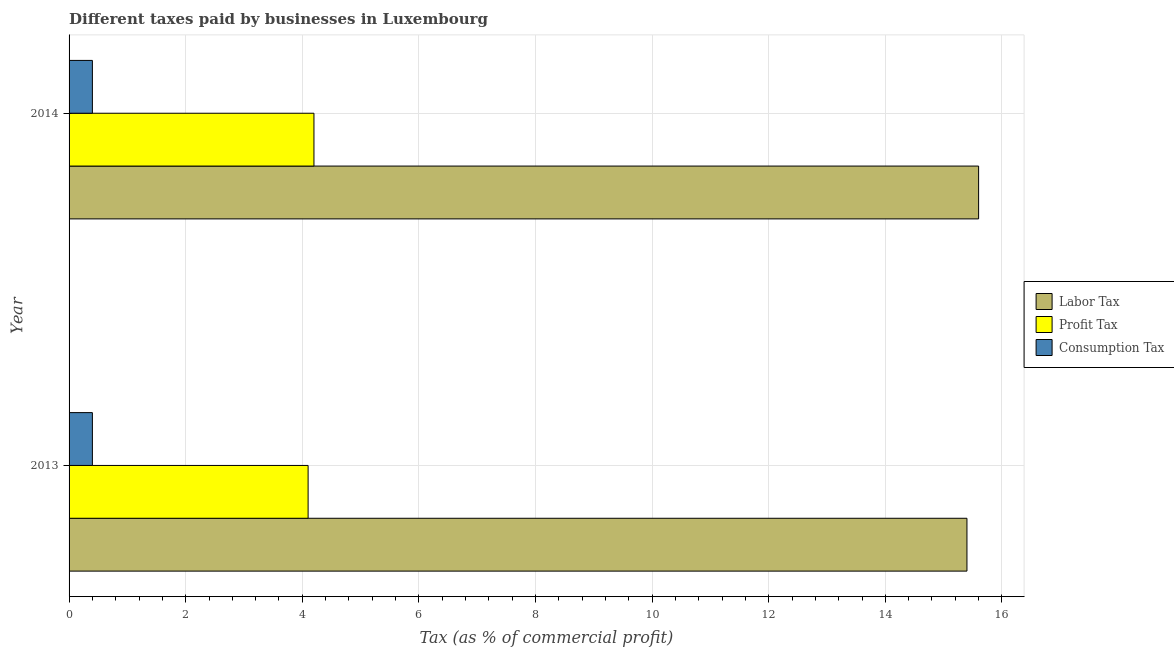How many different coloured bars are there?
Your response must be concise. 3. Are the number of bars per tick equal to the number of legend labels?
Keep it short and to the point. Yes. Are the number of bars on each tick of the Y-axis equal?
Keep it short and to the point. Yes. How many bars are there on the 2nd tick from the top?
Your response must be concise. 3. What is the label of the 1st group of bars from the top?
Ensure brevity in your answer.  2014. What is the percentage of consumption tax in 2014?
Your response must be concise. 0.4. Across all years, what is the maximum percentage of consumption tax?
Provide a short and direct response. 0.4. In which year was the percentage of consumption tax minimum?
Your answer should be very brief. 2013. What is the total percentage of consumption tax in the graph?
Your response must be concise. 0.8. What is the difference between the percentage of labor tax in 2013 and the percentage of consumption tax in 2014?
Keep it short and to the point. 15. What is the average percentage of consumption tax per year?
Provide a short and direct response. 0.4. What is the ratio of the percentage of consumption tax in 2013 to that in 2014?
Ensure brevity in your answer.  1. Is the percentage of profit tax in 2013 less than that in 2014?
Your answer should be very brief. Yes. Is the difference between the percentage of profit tax in 2013 and 2014 greater than the difference between the percentage of consumption tax in 2013 and 2014?
Keep it short and to the point. No. In how many years, is the percentage of consumption tax greater than the average percentage of consumption tax taken over all years?
Make the answer very short. 0. What does the 3rd bar from the top in 2013 represents?
Keep it short and to the point. Labor Tax. What does the 3rd bar from the bottom in 2014 represents?
Provide a short and direct response. Consumption Tax. What is the difference between two consecutive major ticks on the X-axis?
Provide a short and direct response. 2. Are the values on the major ticks of X-axis written in scientific E-notation?
Provide a succinct answer. No. Where does the legend appear in the graph?
Make the answer very short. Center right. How are the legend labels stacked?
Keep it short and to the point. Vertical. What is the title of the graph?
Provide a short and direct response. Different taxes paid by businesses in Luxembourg. What is the label or title of the X-axis?
Your answer should be compact. Tax (as % of commercial profit). What is the label or title of the Y-axis?
Provide a short and direct response. Year. What is the Tax (as % of commercial profit) of Consumption Tax in 2014?
Offer a very short reply. 0.4. Across all years, what is the maximum Tax (as % of commercial profit) in Profit Tax?
Your response must be concise. 4.2. Across all years, what is the minimum Tax (as % of commercial profit) in Consumption Tax?
Your answer should be very brief. 0.4. What is the total Tax (as % of commercial profit) of Labor Tax in the graph?
Provide a succinct answer. 31. What is the total Tax (as % of commercial profit) in Profit Tax in the graph?
Provide a succinct answer. 8.3. What is the total Tax (as % of commercial profit) of Consumption Tax in the graph?
Give a very brief answer. 0.8. What is the difference between the Tax (as % of commercial profit) in Profit Tax in 2013 and that in 2014?
Ensure brevity in your answer.  -0.1. What is the difference between the Tax (as % of commercial profit) of Labor Tax in 2013 and the Tax (as % of commercial profit) of Profit Tax in 2014?
Keep it short and to the point. 11.2. What is the difference between the Tax (as % of commercial profit) in Profit Tax in 2013 and the Tax (as % of commercial profit) in Consumption Tax in 2014?
Your answer should be compact. 3.7. What is the average Tax (as % of commercial profit) in Profit Tax per year?
Make the answer very short. 4.15. What is the average Tax (as % of commercial profit) of Consumption Tax per year?
Give a very brief answer. 0.4. In the year 2013, what is the difference between the Tax (as % of commercial profit) in Labor Tax and Tax (as % of commercial profit) in Consumption Tax?
Keep it short and to the point. 15. In the year 2013, what is the difference between the Tax (as % of commercial profit) of Profit Tax and Tax (as % of commercial profit) of Consumption Tax?
Keep it short and to the point. 3.7. In the year 2014, what is the difference between the Tax (as % of commercial profit) of Labor Tax and Tax (as % of commercial profit) of Profit Tax?
Provide a short and direct response. 11.4. In the year 2014, what is the difference between the Tax (as % of commercial profit) of Labor Tax and Tax (as % of commercial profit) of Consumption Tax?
Make the answer very short. 15.2. In the year 2014, what is the difference between the Tax (as % of commercial profit) in Profit Tax and Tax (as % of commercial profit) in Consumption Tax?
Make the answer very short. 3.8. What is the ratio of the Tax (as % of commercial profit) in Labor Tax in 2013 to that in 2014?
Provide a short and direct response. 0.99. What is the ratio of the Tax (as % of commercial profit) in Profit Tax in 2013 to that in 2014?
Ensure brevity in your answer.  0.98. What is the difference between the highest and the second highest Tax (as % of commercial profit) of Labor Tax?
Ensure brevity in your answer.  0.2. What is the difference between the highest and the second highest Tax (as % of commercial profit) of Profit Tax?
Your answer should be very brief. 0.1. What is the difference between the highest and the lowest Tax (as % of commercial profit) of Consumption Tax?
Offer a very short reply. 0. 